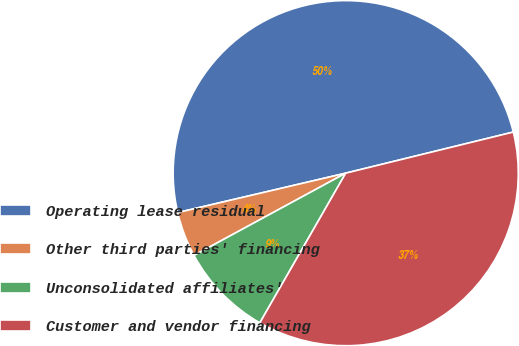Convert chart to OTSL. <chart><loc_0><loc_0><loc_500><loc_500><pie_chart><fcel>Operating lease residual<fcel>Other third parties' financing<fcel>Unconsolidated affiliates'<fcel>Customer and vendor financing<nl><fcel>49.84%<fcel>4.24%<fcel>8.8%<fcel>37.12%<nl></chart> 